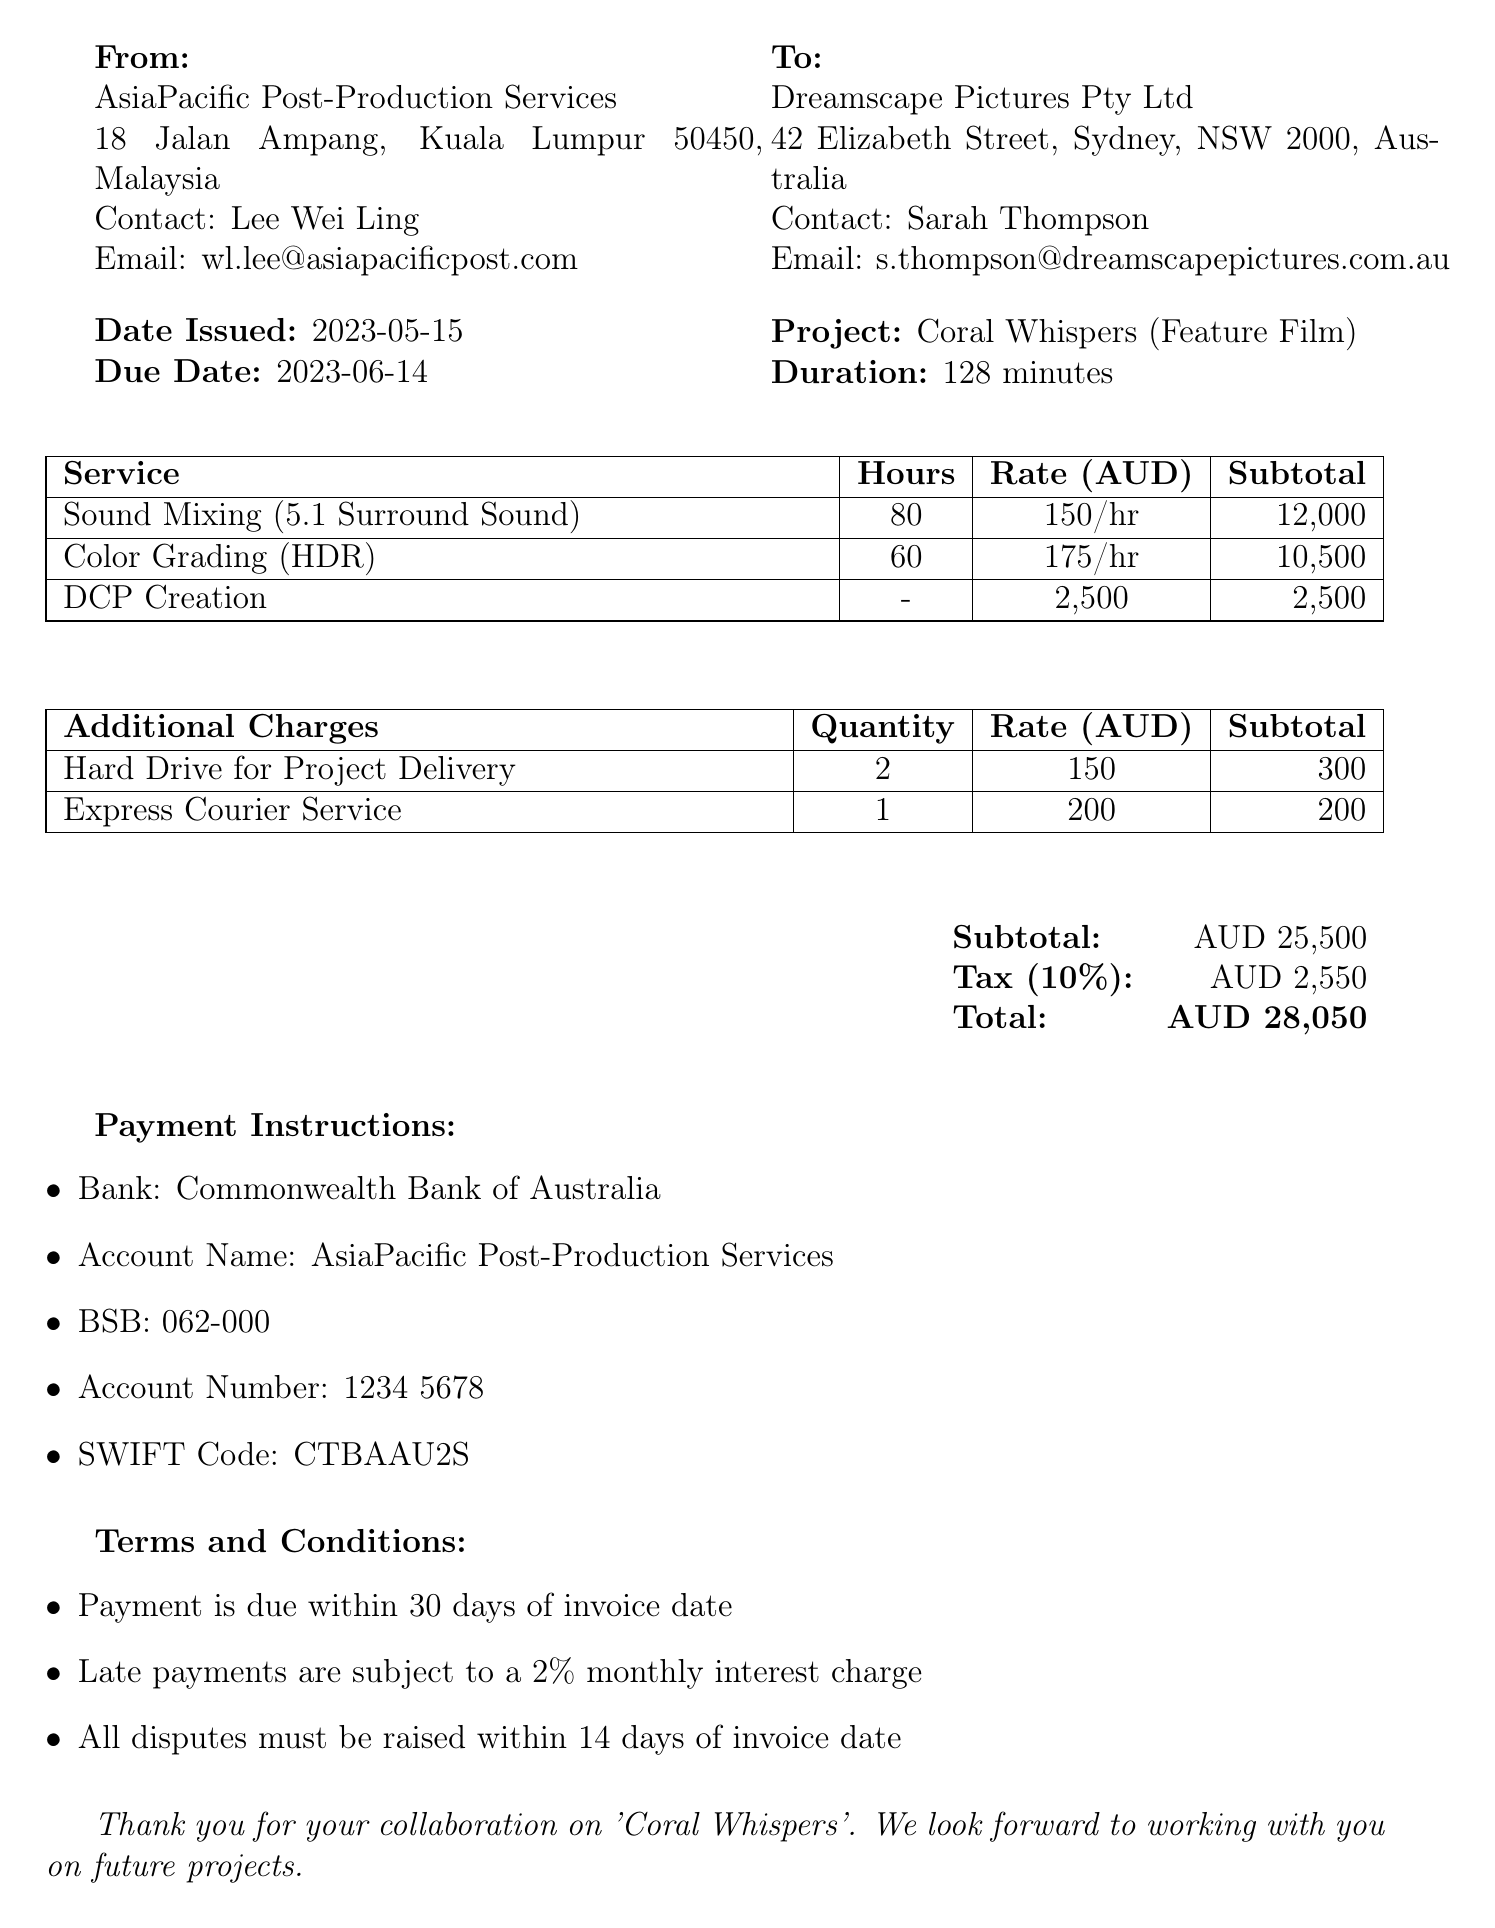what is the invoice number? The invoice number is specified in the document under the invoice details section.
Answer: INV-2023-0542 who is the contact person for the client? The contact person for the client is mentioned in the client info section.
Answer: Sarah Thompson what is the due date for payment? The due date is provided in the invoice details section of the document.
Answer: 2023-06-14 how many hours were dedicated to sound mixing? The number of hours for sound mixing is noted in the services rendered table.
Answer: 80 what is the subtotal for color grading? The subtotal for color grading is stated in the services rendered section.
Answer: 10500 what is the total amount due? The total amount due is calculated and presented at the end of the payment details section.
Answer: 28050 what percentage is the tax applied? The tax rate is indicated in the payment details section of the invoice.
Answer: 10% what is included in the additional charges? Additional charges are listed and summarized in a specific section of the document.
Answer: Hard Drive for Project Delivery and Express Courier Service what is the payment instruction bank name? The bank name for payment instructions is clearly mentioned in the payment instructions section.
Answer: Commonwealth Bank of Australia 